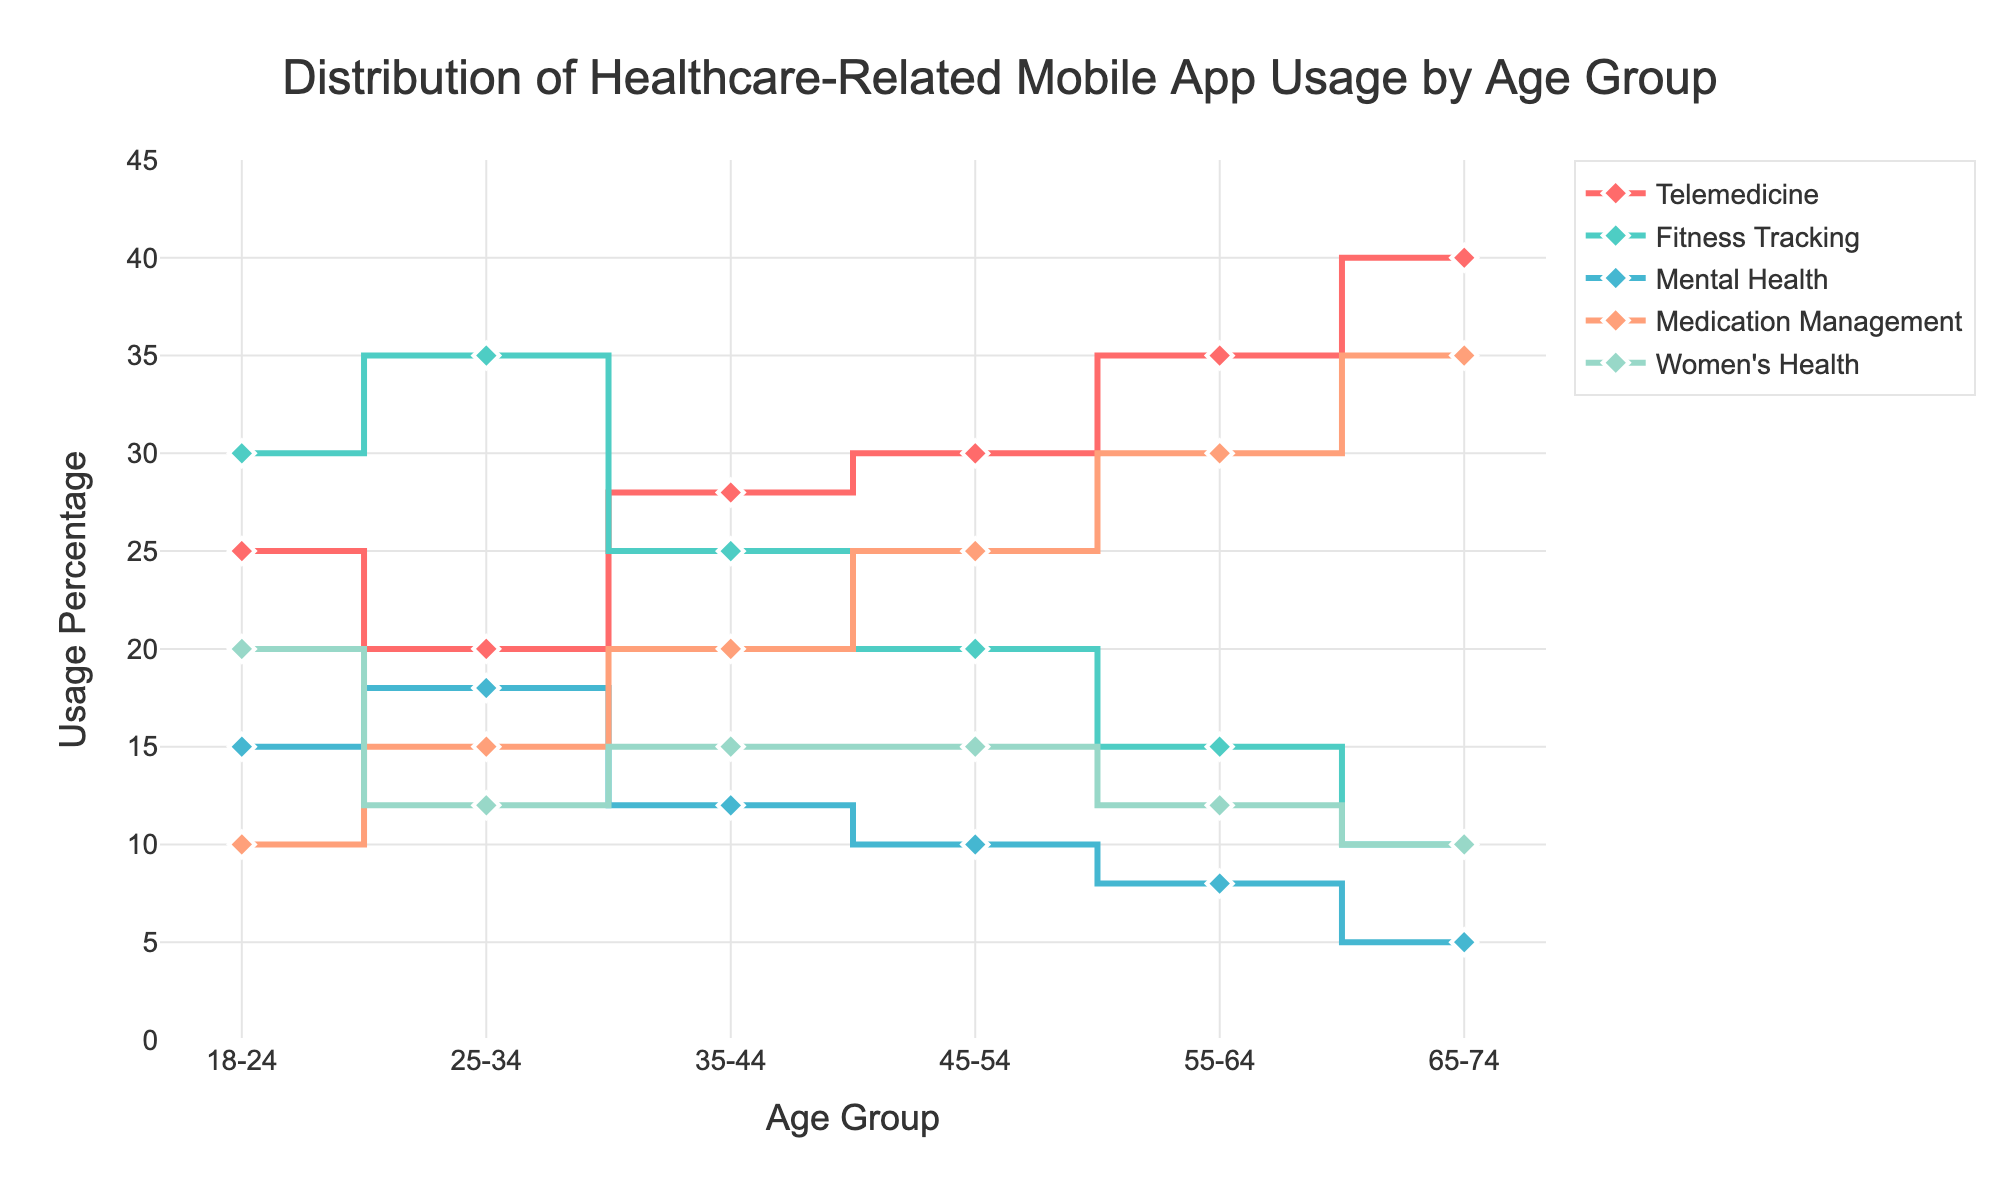What is the title of the plot? The title of the plot is usually displayed prominently at the top of the figure. In this case, the title is "Distribution of Healthcare-Related Mobile App Usage by Age Group".
Answer: Distribution of Healthcare-Related Mobile App Usage by Age Group Which age group has the highest usage percentage for Telemedicine apps? To answer this question, locate the Telemedicine line on the plot and find the highest point on the y-axis. The highest usage percentage for Telemedicine is in the 65-74 age group at 40%.
Answer: 65-74 Does Fitness Tracking app usage increase or decrease with age? To determine this, follow the Fitness Tracking line from left (younger age groups) to right (older age groups). The usage percentage starts at 30% (18-24) and decreases to 10% (65-74), indicating a decrease.
Answer: Decrease What is the difference in Mental Health app usage between the 18-24 and 25-34 age groups? Locate the Mental Health usage percentages for the 18-24 age group (15%) and the 25-34 age group (18%). Calculate the difference: 18% - 15% = 3%.
Answer: 3% Which healthcare app sees the largest increase in usage percentage as the age group increases from 18-24 to 65-74? Compare the starting and ending points of each app’s line. Telemedicine starts at 25% (18-24) and ends at 40% (65-74), showing a 15% increase - the largest among all apps.
Answer: Telemedicine For the 35-44 age group, which app has the lowest usage percentage? Locate the data points for the 35-44 age group and identify the lowest point on the y-axis. The lowest usage percentage is for Mental Health apps at 12%.
Answer: Mental Health Calculate the average usage percentage of Women's Health apps across all age groups. Add up the Women's Health usage percentages for all age groups: 20% (18-24) + 12% (25-34) + 15% (35-44) + 15% (45-54) + 12% (55-64) + 10% (65-74) = 84%. Divide by the number of age groups (6): 84% / 6 = 14%.
Answer: 14% Which two age groups have equal usage percentages for Medication Management apps? Scan the Medication Management line to find any age groups with the same y-axis value. Both the 35-44 and 45-54 age groups have a usage percentage of 25%.
Answer: 35-44 and 45-54 Between the 55-64 and 65-74 age groups, which one shows a higher average usage percentage across all apps? Calculate the average for each group:
55-64: (35 + 15 + 8 + 30 + 12) / 5 = 20%
65-74: (40 + 10 + 5 + 35 + 10) / 5 = 20%
Both groups have the same average usage percentage of 20%.
Answer: Equal Is there any app that shows a decrease in usage in every subsequent age group? Review each app’s line and determine if any continuously decreases as age groups increase. The Fitness Tracking app usage continuously decreases across all age groups.
Answer: Fitness Tracking 